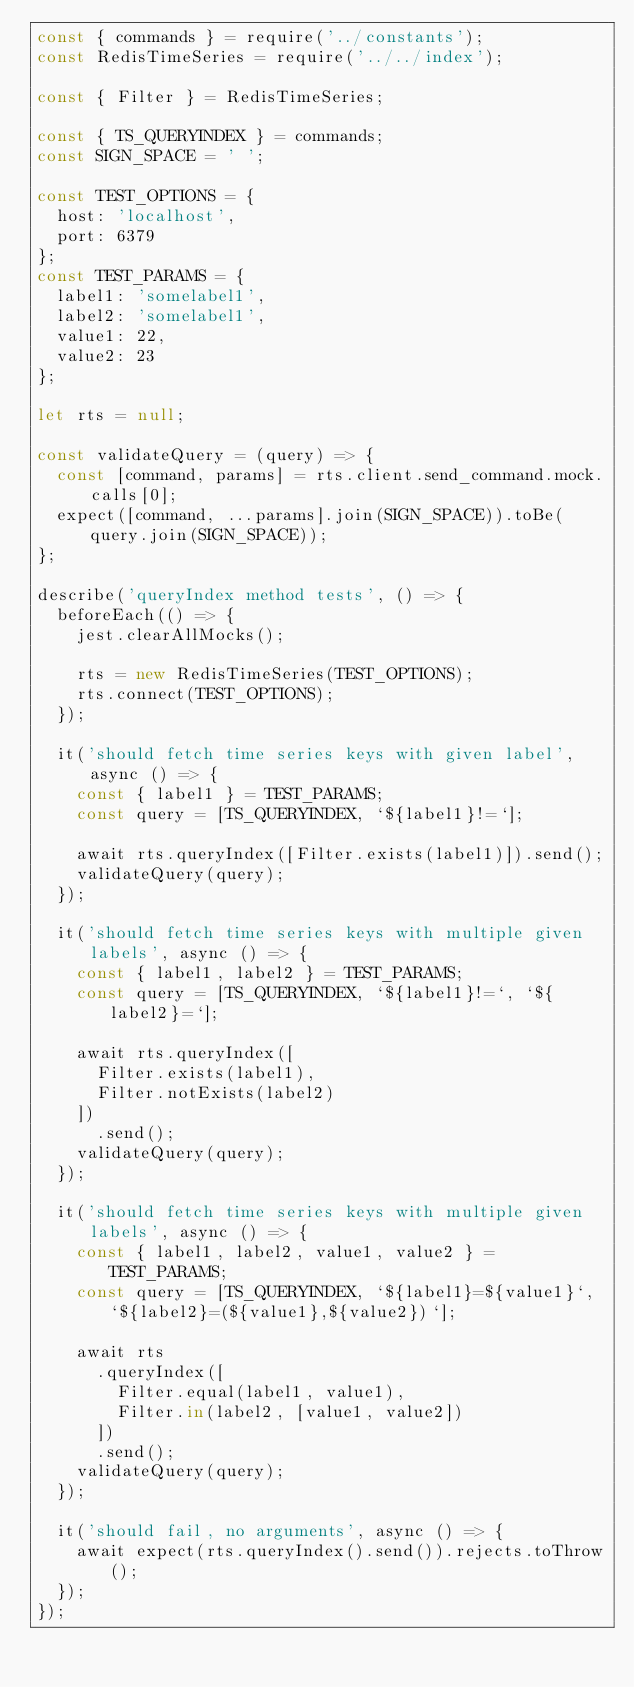Convert code to text. <code><loc_0><loc_0><loc_500><loc_500><_JavaScript_>const { commands } = require('../constants');
const RedisTimeSeries = require('../../index');

const { Filter } = RedisTimeSeries;

const { TS_QUERYINDEX } = commands;
const SIGN_SPACE = ' ';

const TEST_OPTIONS = {
  host: 'localhost',
  port: 6379
};
const TEST_PARAMS = {
  label1: 'somelabel1',
  label2: 'somelabel1',
  value1: 22,
  value2: 23
};

let rts = null;

const validateQuery = (query) => {
  const [command, params] = rts.client.send_command.mock.calls[0];
  expect([command, ...params].join(SIGN_SPACE)).toBe(query.join(SIGN_SPACE));
};

describe('queryIndex method tests', () => {
  beforeEach(() => {
    jest.clearAllMocks();

    rts = new RedisTimeSeries(TEST_OPTIONS);
    rts.connect(TEST_OPTIONS);
  });

  it('should fetch time series keys with given label', async () => {
    const { label1 } = TEST_PARAMS;
    const query = [TS_QUERYINDEX, `${label1}!=`];

    await rts.queryIndex([Filter.exists(label1)]).send();
    validateQuery(query);
  });

  it('should fetch time series keys with multiple given labels', async () => {
    const { label1, label2 } = TEST_PARAMS;
    const query = [TS_QUERYINDEX, `${label1}!=`, `${label2}=`];

    await rts.queryIndex([
      Filter.exists(label1),
      Filter.notExists(label2)
    ])
      .send();
    validateQuery(query);
  });

  it('should fetch time series keys with multiple given labels', async () => {
    const { label1, label2, value1, value2 } = TEST_PARAMS;
    const query = [TS_QUERYINDEX, `${label1}=${value1}`, `${label2}=(${value1},${value2})`];

    await rts
      .queryIndex([
        Filter.equal(label1, value1),
        Filter.in(label2, [value1, value2])
      ])
      .send();
    validateQuery(query);
  });

  it('should fail, no arguments', async () => {
    await expect(rts.queryIndex().send()).rejects.toThrow();
  });
});
</code> 